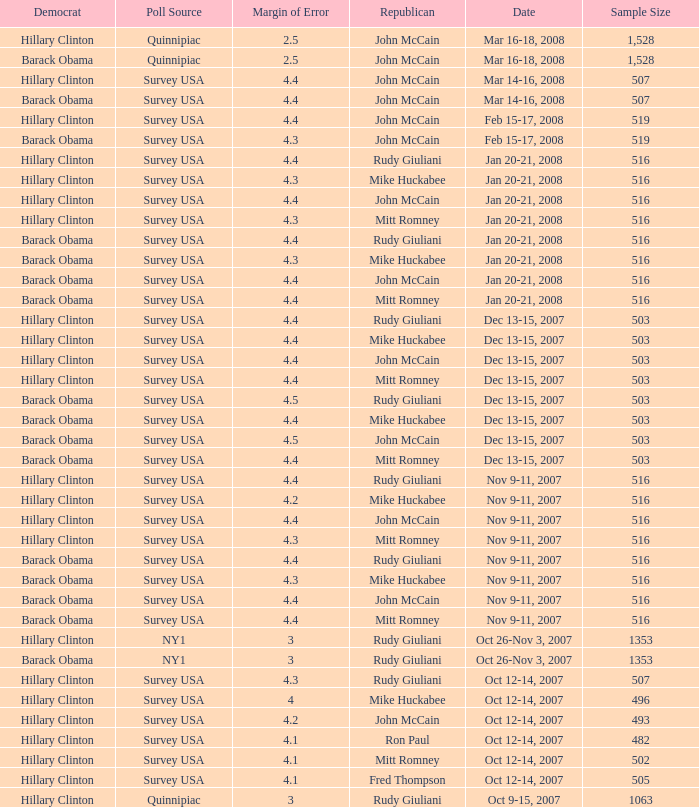What was the date of the poll with a sample size of 496 where Republican Mike Huckabee was chosen? Oct 12-14, 2007. 